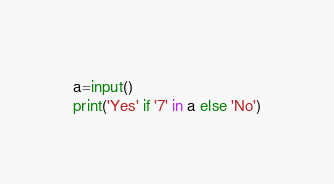<code> <loc_0><loc_0><loc_500><loc_500><_Python_>a=input()
print('Yes' if '7' in a else 'No')</code> 